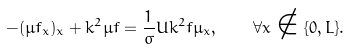<formula> <loc_0><loc_0><loc_500><loc_500>- ( \mu f _ { x } ) _ { x } + k ^ { 2 } \mu f = \frac { 1 } { \sigma } U k ^ { 2 } f \mu _ { x } , \quad \forall x \notin \{ 0 , L \} .</formula> 